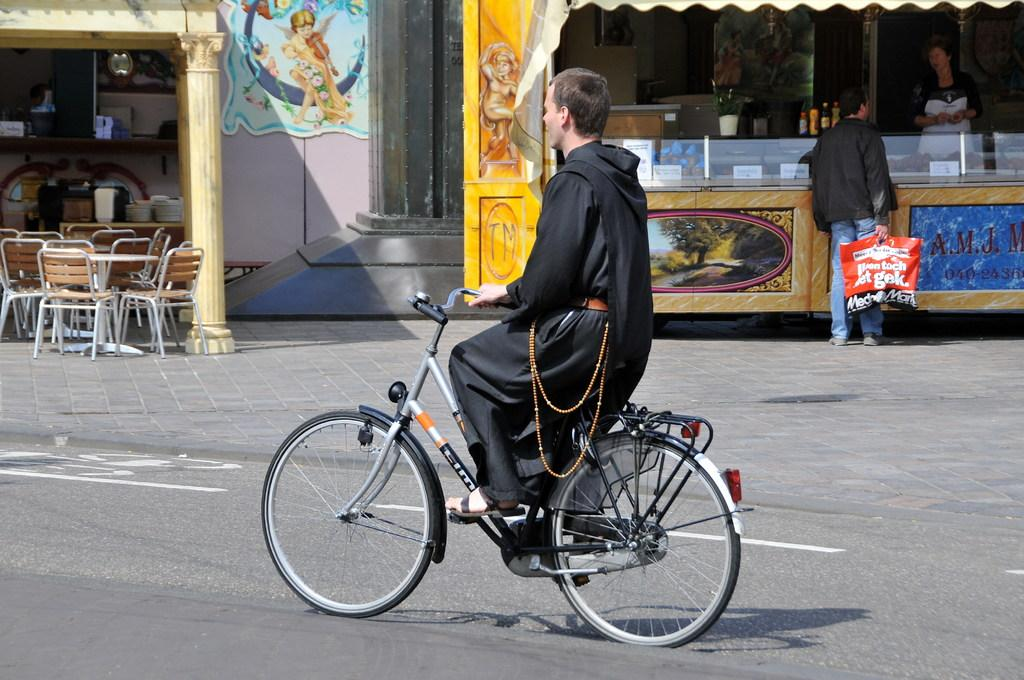What is the main subject of the image? There is a person riding a bicycle in the image. What can be seen to the right of the person? There are two stalls to the right of the person. What is located in front of the stalls? In front of the stalls, there is a table. What is associated with the table? There are chairs associated with the table. How many dolls are sitting on the beds in the image? There are no dolls or beds present in the image. 